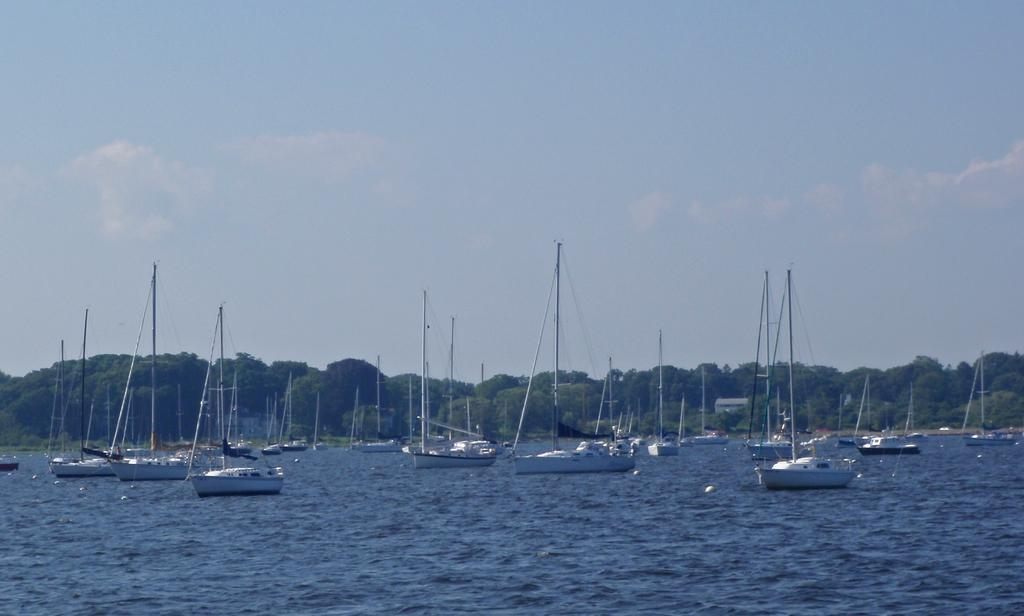What is happening in the image? There are boats sailing on the water in the image. What can be seen in the background of the image? There are trees visible in the background of the image. What is visible above the boats and trees in the image? The sky is visible in the image. What type of spy equipment can be seen hidden among the trees in the image? There is no spy equipment present in the image; it only features boats sailing on the water and trees in the background. What type of bird can be seen perched on the shade in the image? There is no bird or shade present in the image. 